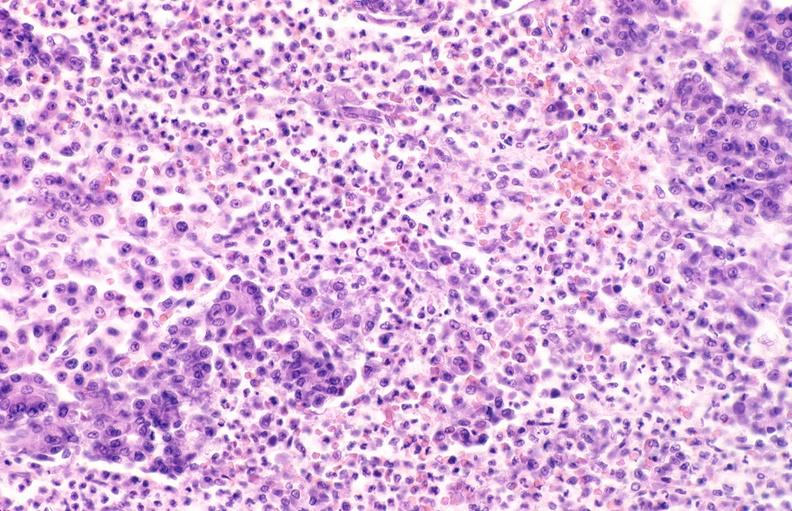does this image show pancreatic fat necrosis?
Answer the question using a single word or phrase. Yes 